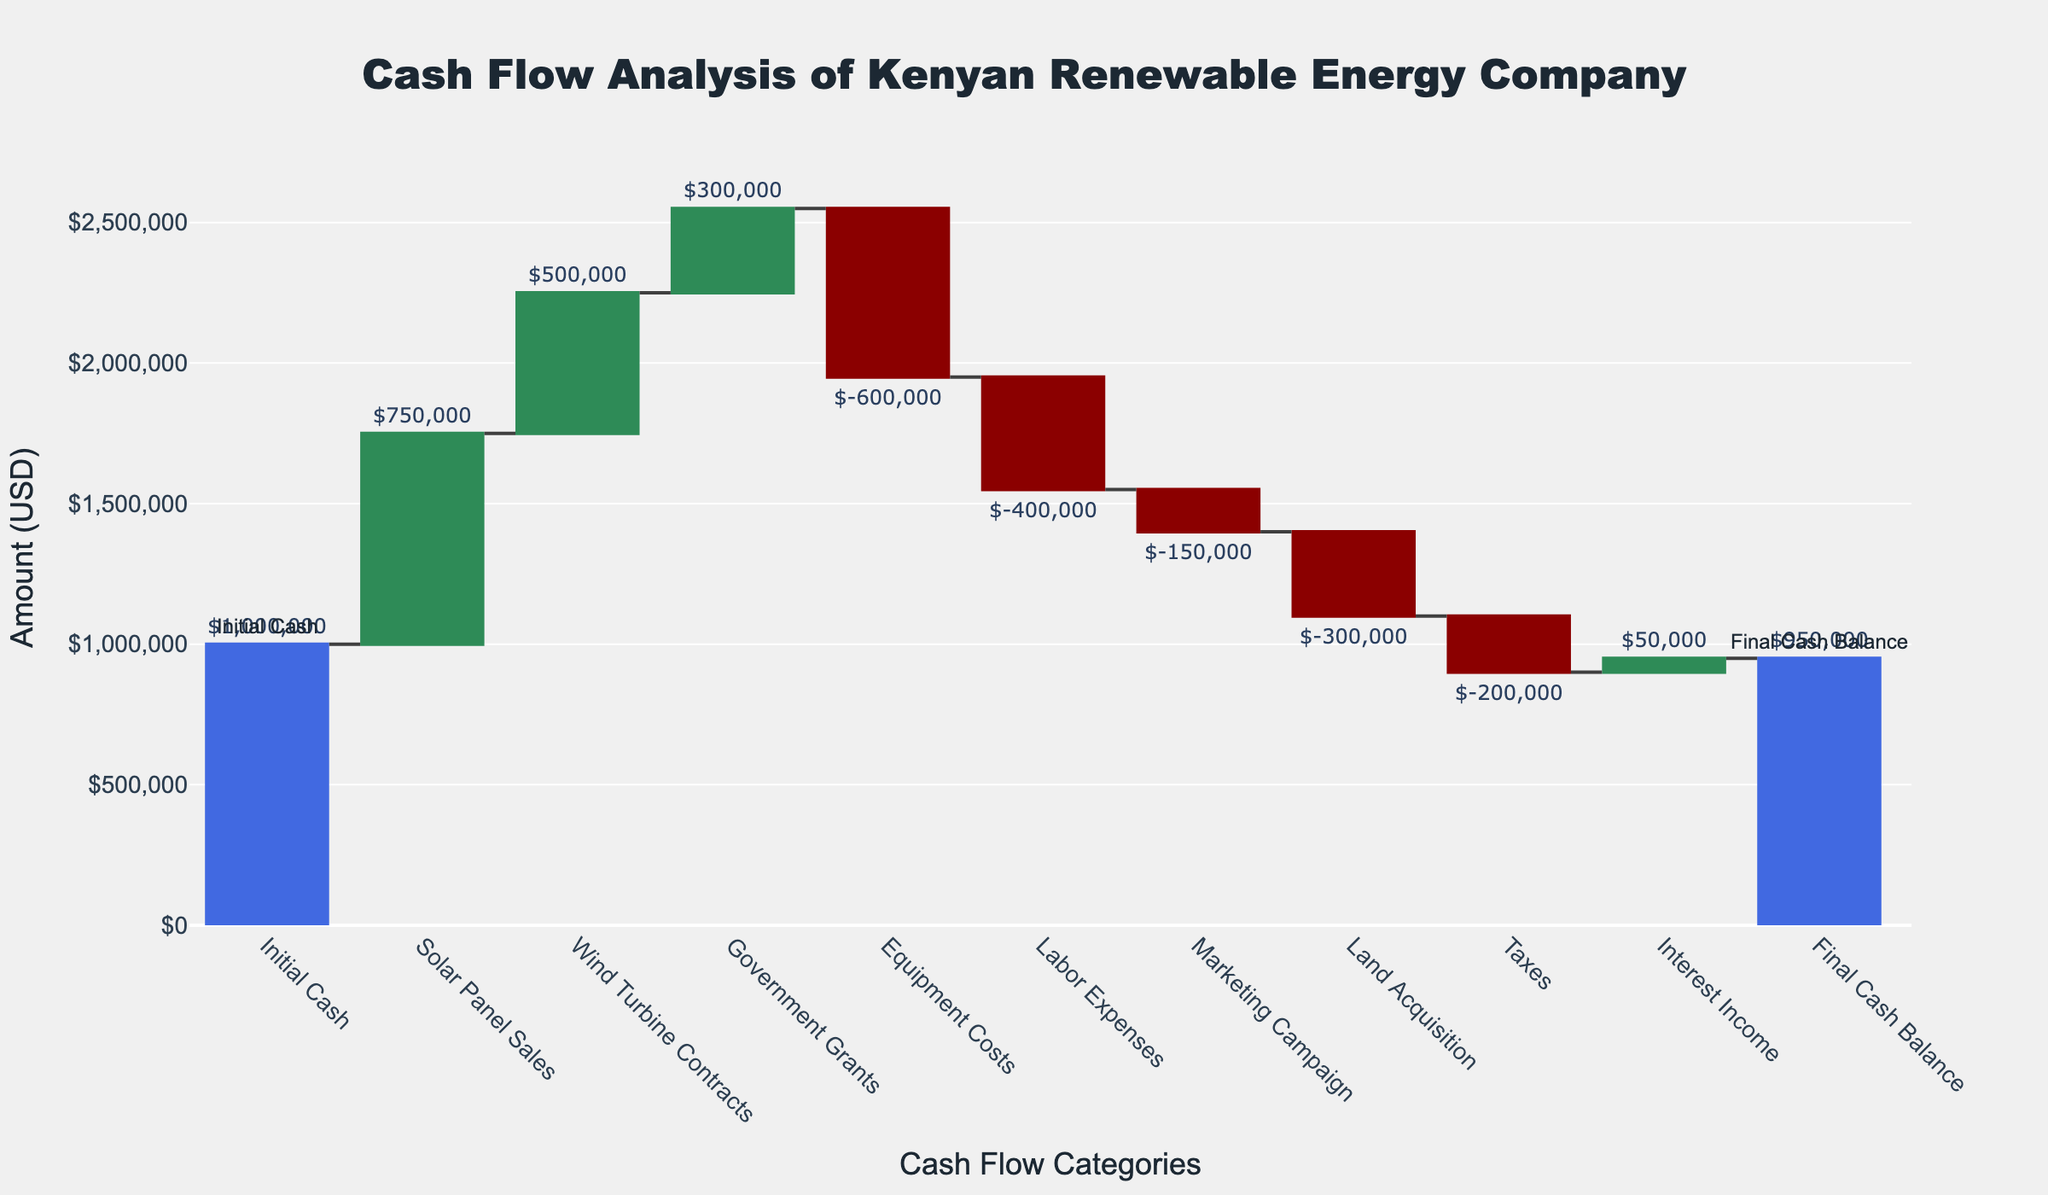What is the initial cash balance for the Kenyan renewable energy company? The chart shows an initial column labeled "Initial Cash" with a value of $1,000,000, represented in green.
Answer: $1,000,000 How much revenue is generated from Solar Panel Sales? The column labeled "Solar Panel Sales" shows a positive change in cash flow, with the value placed at the top of the column denoting $750,000.
Answer: $750,000 What amount was allocated for Equipment Costs? The column labeled "Equipment Costs" is in red, indicating a deduction in cash flow, with the value of -$600,000 at the top of the column.
Answer: -$600,000 Which categories positively contributed to the cash flow? The green columns are indicative of positive contributions. The categories with positive values are "Solar Panel Sales," "Wind Turbine Contracts," "Government Grants," and "Interest Income."
Answer: Solar Panel Sales, Wind Turbine Contracts, Government Grants, Interest Income What is the net impact of all the government-related cash flows (Government Grants and Taxes)? Government Grants add $300,000 while Taxes subtract $200,000. Adding these amounts together results in a net governmental cash flow of $100,000.
Answer: $100,000 What is the final cash balance? The final column, titled "Final Cash Balance," shows an overall positive balance of $950,000, denoted in blue.
Answer: $950,000 Compare the cash inflows from Wind Turbine Contracts with the cash outflows from Labor Expenses. Which one is greater? Wind Turbine Contracts contributed $500,000 whereas Labor Expenses deducted $400,000. By comparison, the cash inflow from Wind Turbine Contracts is greater by $100,000.
Answer: Wind Turbine Contracts How much total cash outflow can be observed for all expenditure-related categories combined (Equipment Costs, Labor Expenses, Marketing Campaign, Land Acquisition, Taxes)? Adding up the expenditures: -$600,000 (Equipment Costs), -$400,000 (Labor Expenses), -$150,000 (Marketing Campaign), -$300,000 (Land Acquisition), and -$200,000 (Taxes) results in a total cash outflow of -$1,650,000.
Answer: -$1,650,000 Which cash flow category has the smallest amount and what is its value? The smallest amount is from the "Interest Income" category, which shows a positive flow of $50,000.
Answer: Interest Income, $50,000 